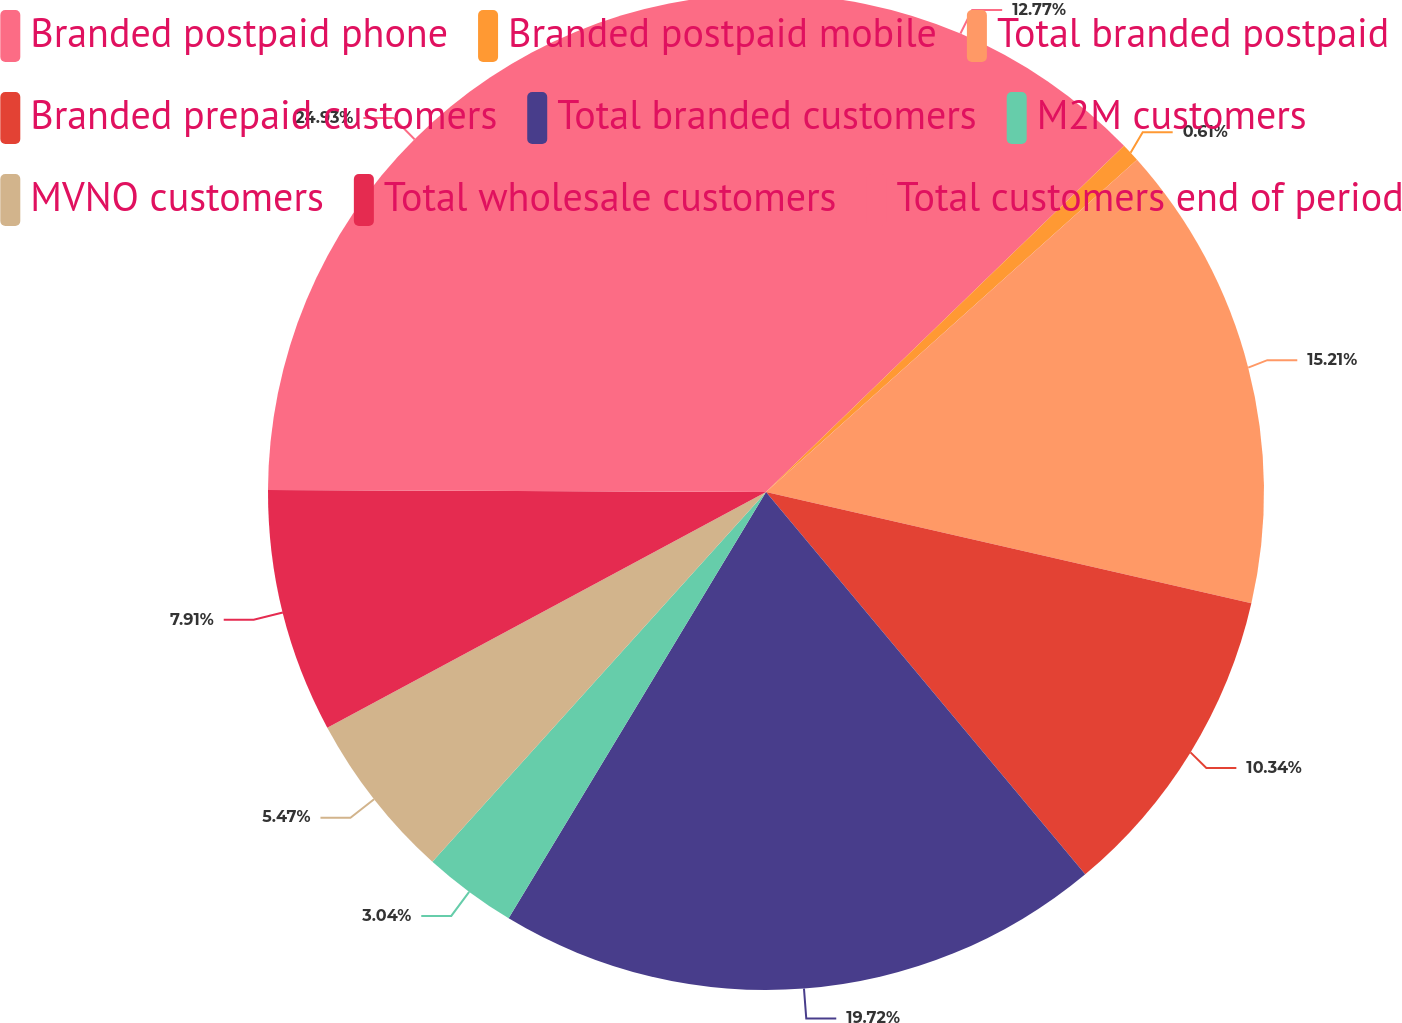Convert chart. <chart><loc_0><loc_0><loc_500><loc_500><pie_chart><fcel>Branded postpaid phone<fcel>Branded postpaid mobile<fcel>Total branded postpaid<fcel>Branded prepaid customers<fcel>Total branded customers<fcel>M2M customers<fcel>MVNO customers<fcel>Total wholesale customers<fcel>Total customers end of period<nl><fcel>12.77%<fcel>0.61%<fcel>15.21%<fcel>10.34%<fcel>19.72%<fcel>3.04%<fcel>5.47%<fcel>7.91%<fcel>24.94%<nl></chart> 